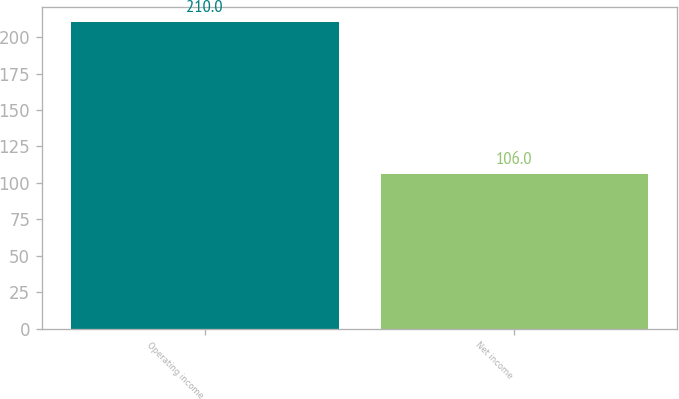Convert chart to OTSL. <chart><loc_0><loc_0><loc_500><loc_500><bar_chart><fcel>Operating income<fcel>Net income<nl><fcel>210<fcel>106<nl></chart> 